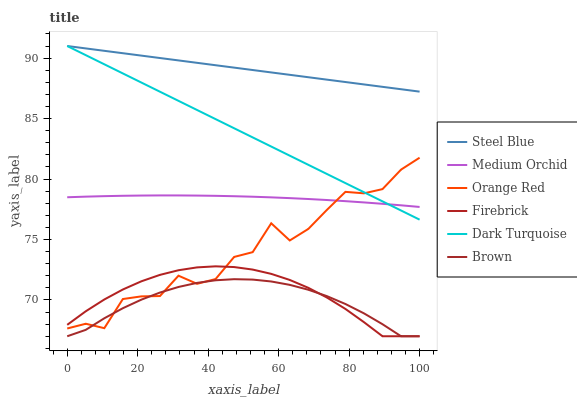Does Brown have the minimum area under the curve?
Answer yes or no. Yes. Does Steel Blue have the maximum area under the curve?
Answer yes or no. Yes. Does Dark Turquoise have the minimum area under the curve?
Answer yes or no. No. Does Dark Turquoise have the maximum area under the curve?
Answer yes or no. No. Is Dark Turquoise the smoothest?
Answer yes or no. Yes. Is Orange Red the roughest?
Answer yes or no. Yes. Is Firebrick the smoothest?
Answer yes or no. No. Is Firebrick the roughest?
Answer yes or no. No. Does Brown have the lowest value?
Answer yes or no. Yes. Does Dark Turquoise have the lowest value?
Answer yes or no. No. Does Steel Blue have the highest value?
Answer yes or no. Yes. Does Firebrick have the highest value?
Answer yes or no. No. Is Brown less than Dark Turquoise?
Answer yes or no. Yes. Is Steel Blue greater than Orange Red?
Answer yes or no. Yes. Does Orange Red intersect Medium Orchid?
Answer yes or no. Yes. Is Orange Red less than Medium Orchid?
Answer yes or no. No. Is Orange Red greater than Medium Orchid?
Answer yes or no. No. Does Brown intersect Dark Turquoise?
Answer yes or no. No. 